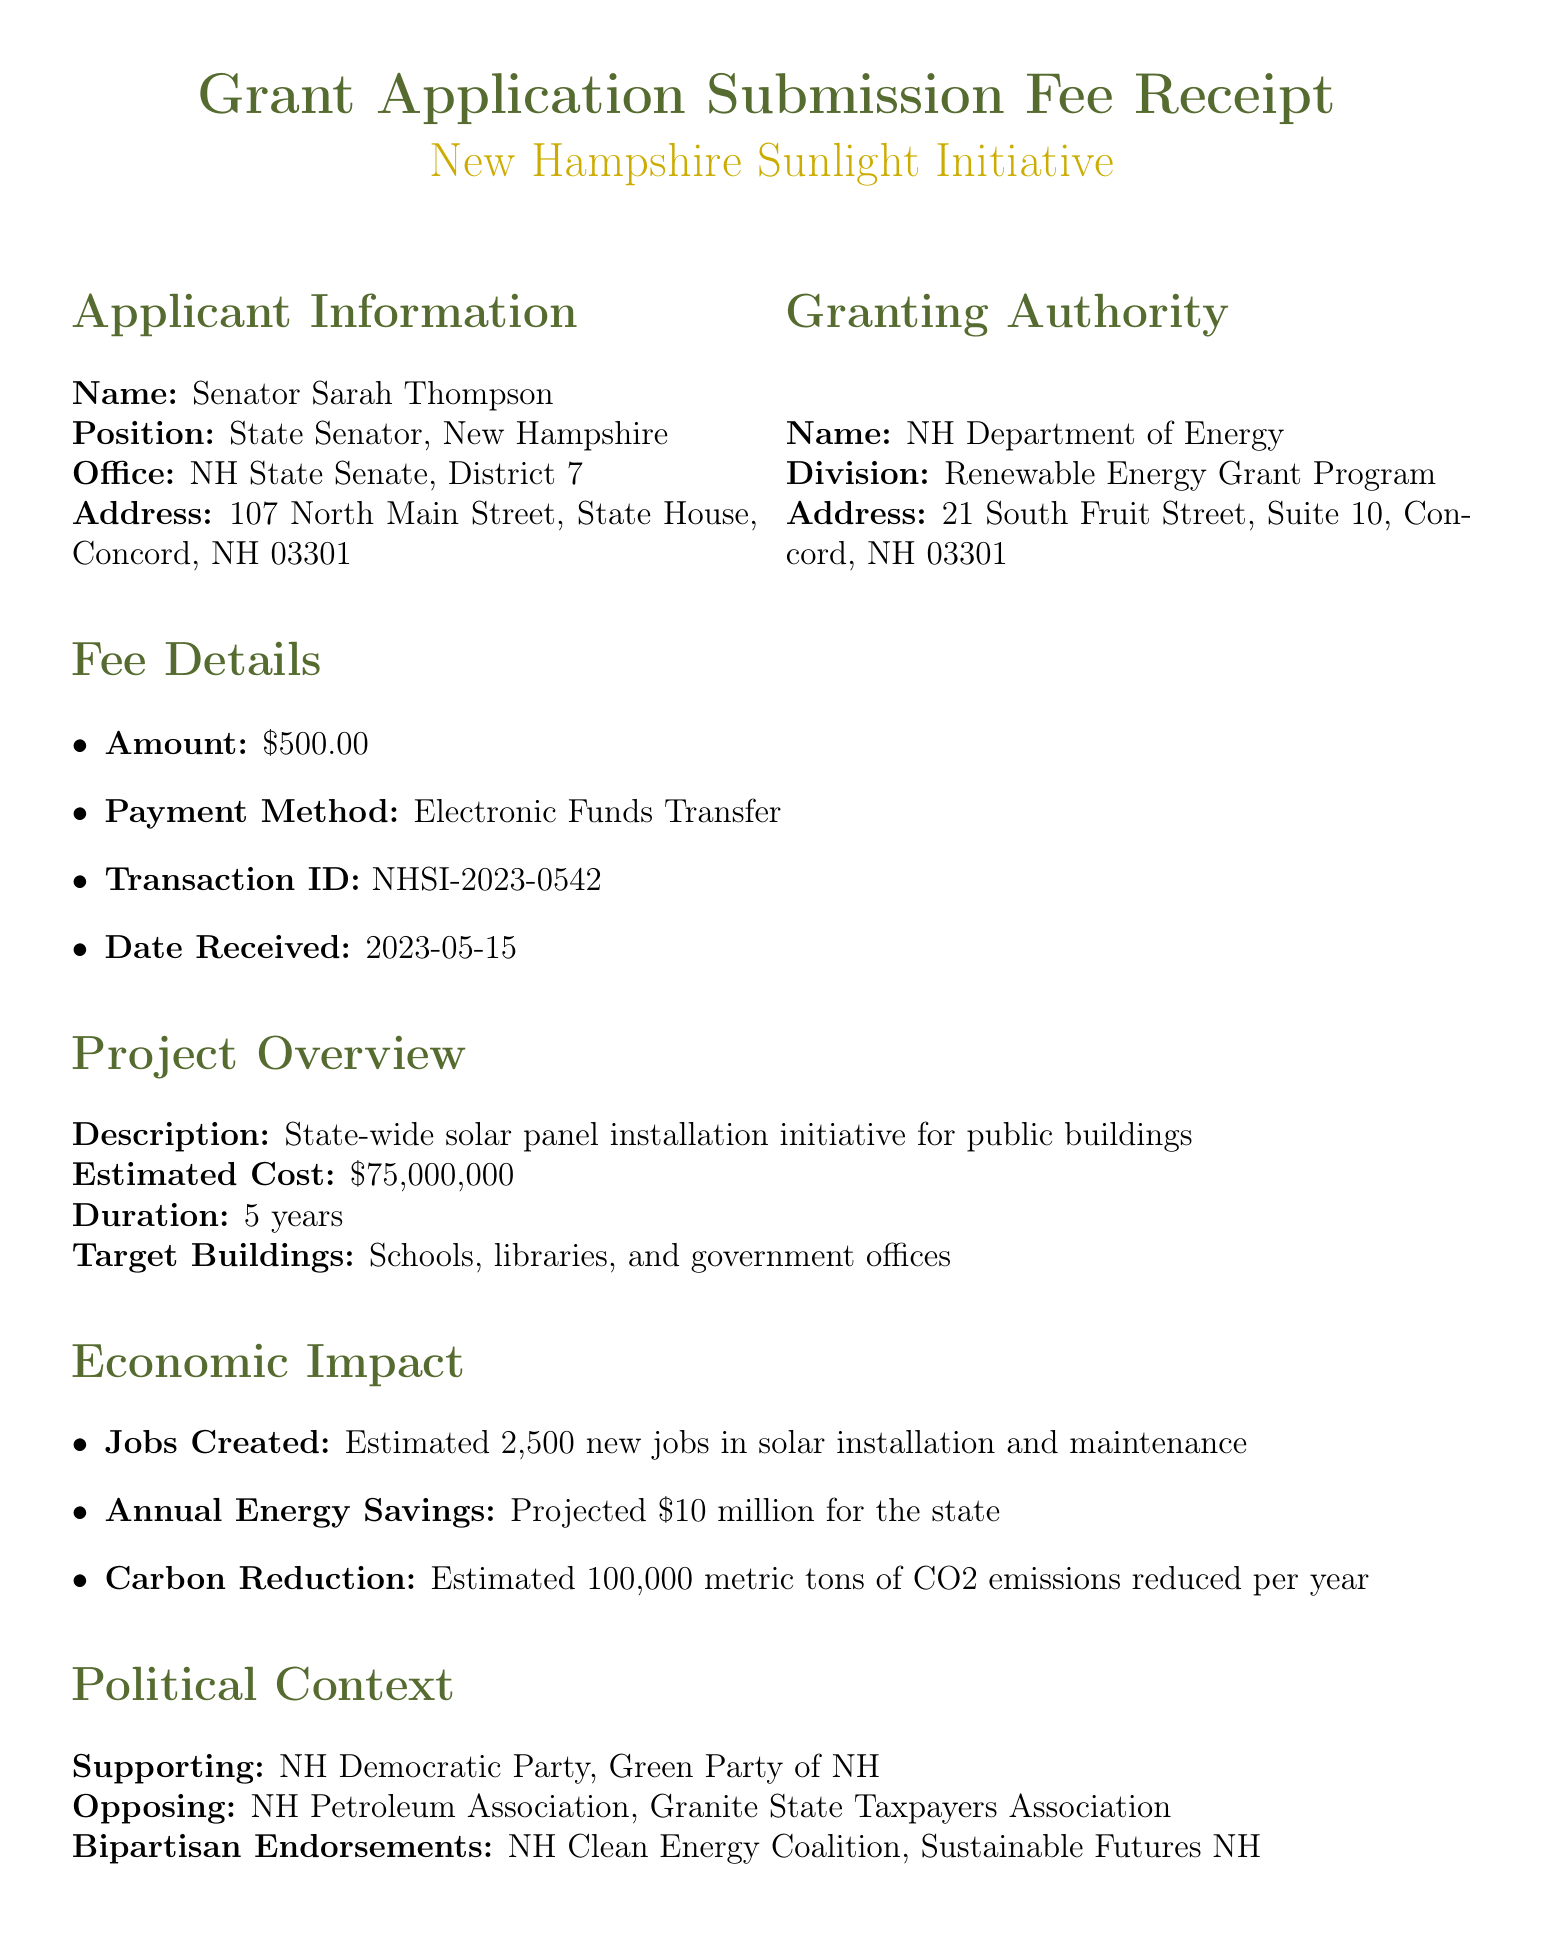What is the name of the initiative? The name of the initiative is mentioned in the document as the project name.
Answer: New Hampshire Sunlight Initiative Who is the applicant? The applicant's name and position are provided in the applicant information section of the document.
Answer: Senator Sarah Thompson What is the amount of the application fee? The fee details section lists the amount that was paid for the grant application submission.
Answer: $500.00 When was the fee received? The date the fee was received is specified in the fee details section.
Answer: 2023-05-15 What is the estimated cost of the project? The project details section includes the estimated cost required for the initiative.
Answer: $75,000,000 How many new jobs are projected to be created? The economic impact section indicates the estimated number of new jobs resulting from the initiative.
Answer: Estimated 2,500 new jobs What percentage of the political context supports the initiative? The supporting parties listed in the political context section suggest a focus on political backing for the initiative.
Answer: New Hampshire Democratic Party, Green Party of New Hampshire What is a disclaimer regarding the application fee? One of the disclaimers specifies conditions regarding the application fee, which is outlined in the document.
Answer: The application fee is non-refundable regardless of the grant decision What is the proposed duration of the project? The project details section specifies how long the initiative is expected to run.
Answer: 5 years 